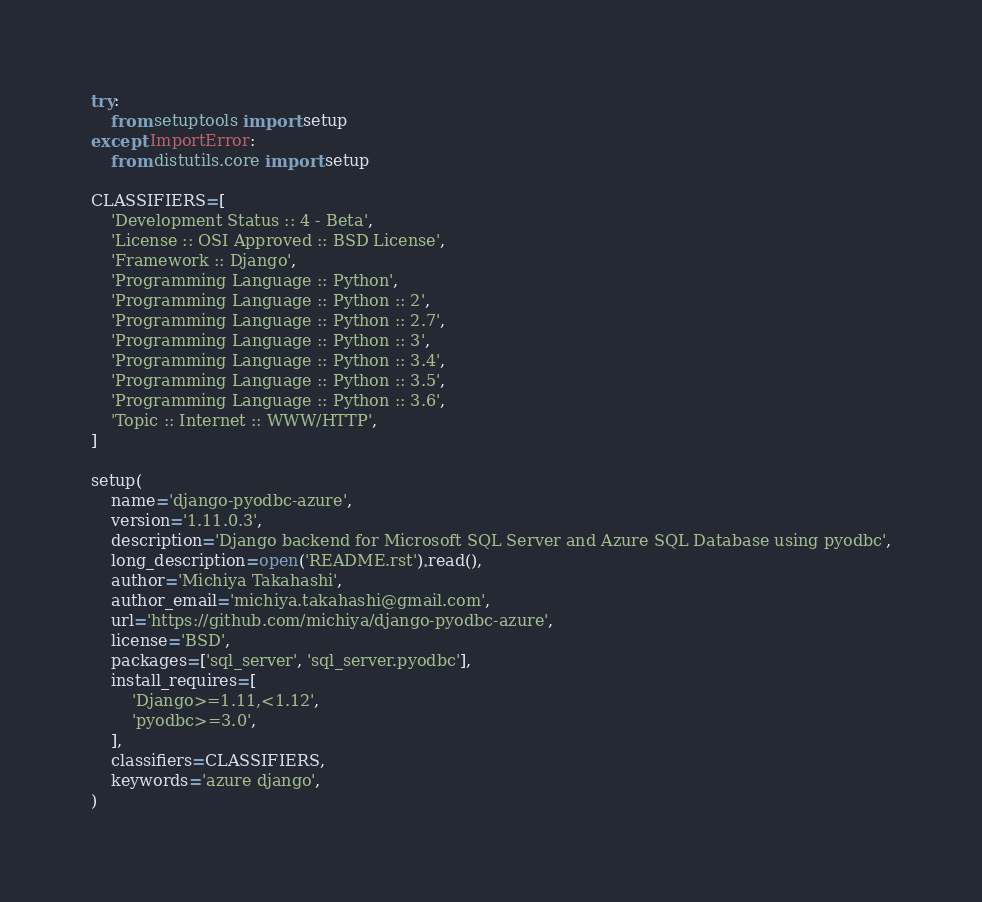<code> <loc_0><loc_0><loc_500><loc_500><_Python_>try:
    from setuptools import setup
except ImportError:
    from distutils.core import setup

CLASSIFIERS=[
    'Development Status :: 4 - Beta',
    'License :: OSI Approved :: BSD License',
    'Framework :: Django',
    'Programming Language :: Python',
    'Programming Language :: Python :: 2',
    'Programming Language :: Python :: 2.7',
    'Programming Language :: Python :: 3',
    'Programming Language :: Python :: 3.4',
    'Programming Language :: Python :: 3.5',
    'Programming Language :: Python :: 3.6',
    'Topic :: Internet :: WWW/HTTP',
]

setup(
    name='django-pyodbc-azure',
    version='1.11.0.3',
    description='Django backend for Microsoft SQL Server and Azure SQL Database using pyodbc',
    long_description=open('README.rst').read(),
    author='Michiya Takahashi',
    author_email='michiya.takahashi@gmail.com',
    url='https://github.com/michiya/django-pyodbc-azure',
    license='BSD',
    packages=['sql_server', 'sql_server.pyodbc'],
    install_requires=[
        'Django>=1.11,<1.12',
        'pyodbc>=3.0',
    ],
    classifiers=CLASSIFIERS,
    keywords='azure django',
)
</code> 